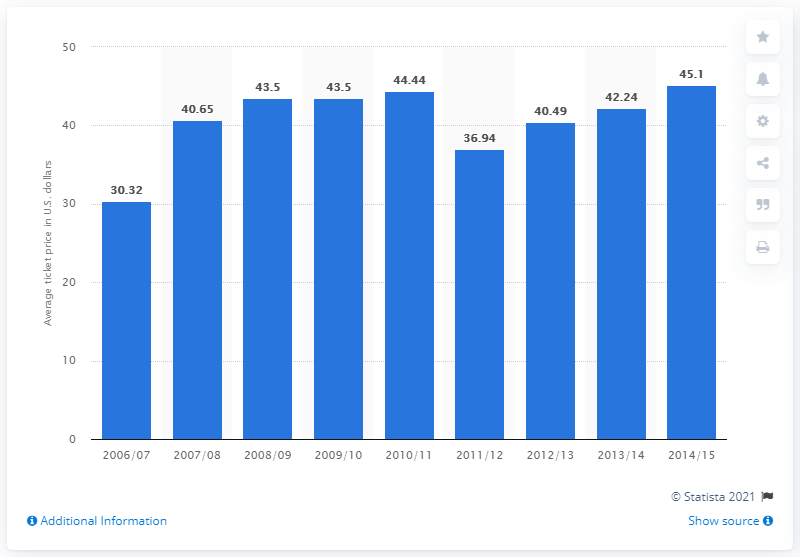Draw attention to some important aspects in this diagram. The average ticket price in 2006 was $30.32. 